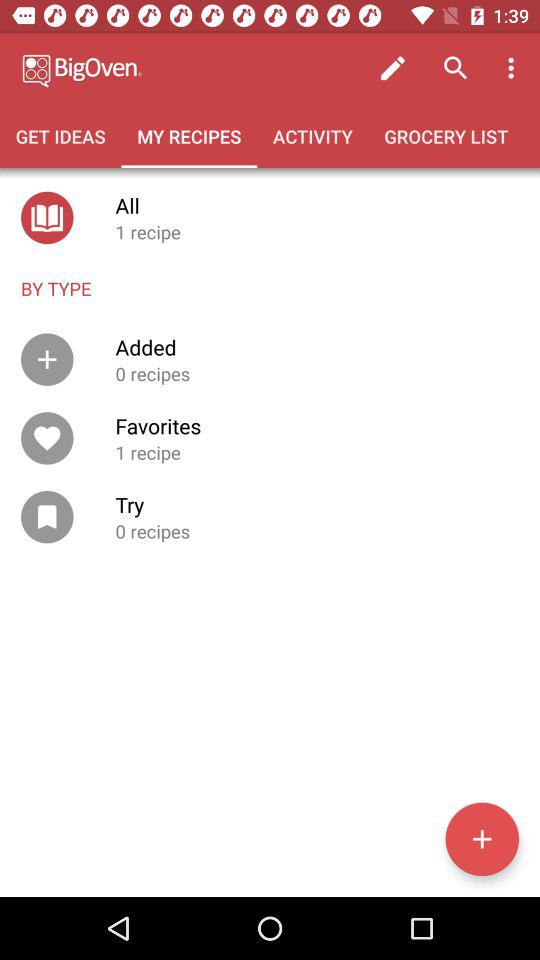Can you tell me about the categories I have for organizing my recipes? Certainly! In the image, there are four categories shown for organizing recipes: 'All,' 'Added,' 'Favorites,' and 'Try.' The 'All' category includes every recipe you've saved to the app. 'Added' appears to be where you can store recipes you've created or inputted yourself, and currently, it has no recipes saved. 'Favorites' is self-explanatory, reserved for the recipes you love most, and there's one recipe there at the moment. Lastly, the 'Try' category seems intended for recipes you're interested in trying out, and it's empty for now. 